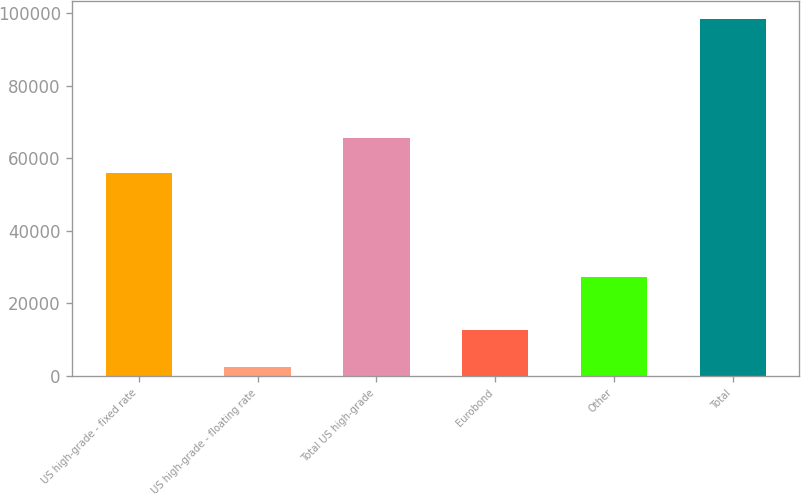<chart> <loc_0><loc_0><loc_500><loc_500><bar_chart><fcel>US high-grade - fixed rate<fcel>US high-grade - floating rate<fcel>Total US high-grade<fcel>Eurobond<fcel>Other<fcel>Total<nl><fcel>55829<fcel>2341<fcel>65423<fcel>12739<fcel>27372<fcel>98281<nl></chart> 